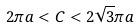<formula> <loc_0><loc_0><loc_500><loc_500>2 \pi a < C < 2 \sqrt { 3 } \pi a</formula> 